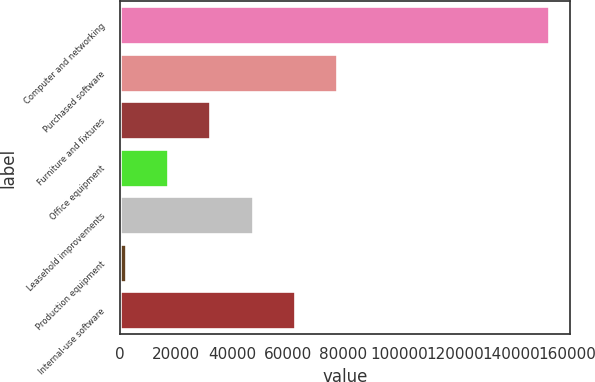<chart> <loc_0><loc_0><loc_500><loc_500><bar_chart><fcel>Computer and networking<fcel>Purchased software<fcel>Furniture and fixtures<fcel>Office equipment<fcel>Leasehold improvements<fcel>Production equipment<fcel>Internal-use software<nl><fcel>153520<fcel>77724<fcel>32246.4<fcel>17087.2<fcel>47405.6<fcel>1928<fcel>62564.8<nl></chart> 